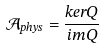Convert formula to latex. <formula><loc_0><loc_0><loc_500><loc_500>\mathcal { A } _ { p h y s } = \frac { k e r Q } { i m Q }</formula> 